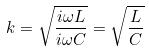<formula> <loc_0><loc_0><loc_500><loc_500>k = \sqrt { \frac { i \omega L } { i \omega C } } = \sqrt { \frac { L } { C } }</formula> 